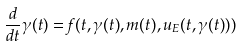<formula> <loc_0><loc_0><loc_500><loc_500>\frac { d } { d t } \gamma ( t ) = f ( t , \gamma ( t ) , m ( t ) , u _ { E } ( t , \gamma ( t ) ) )</formula> 